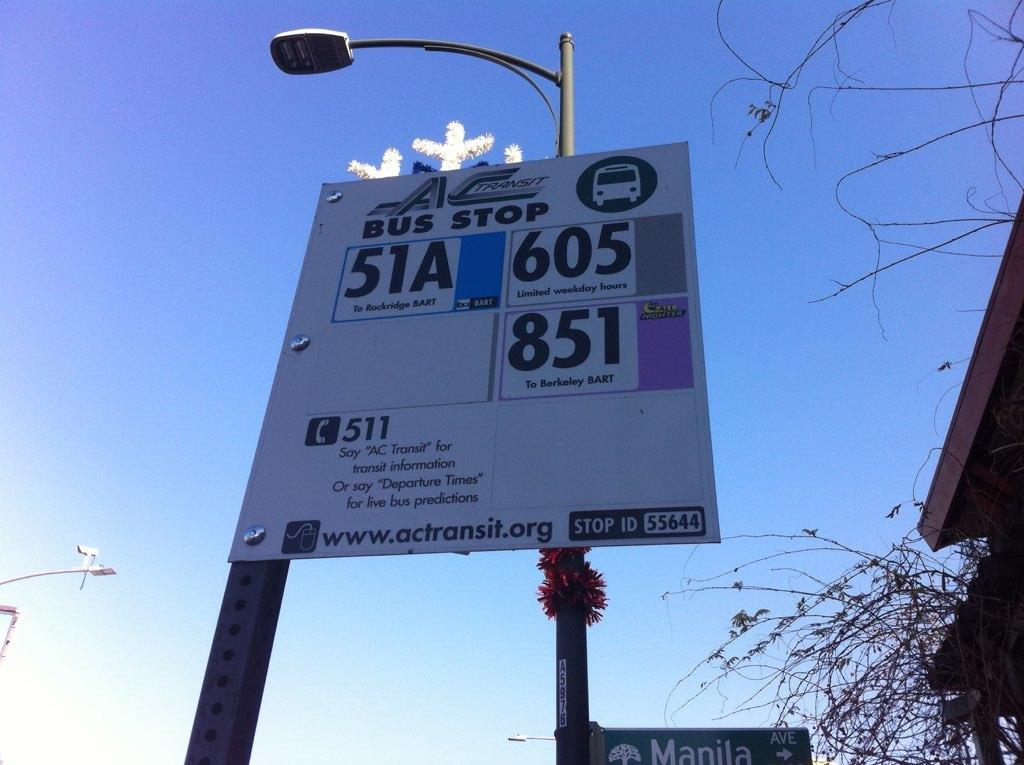<image>
Write a terse but informative summary of the picture. Bus stop 51A is here and call 511 for help. 